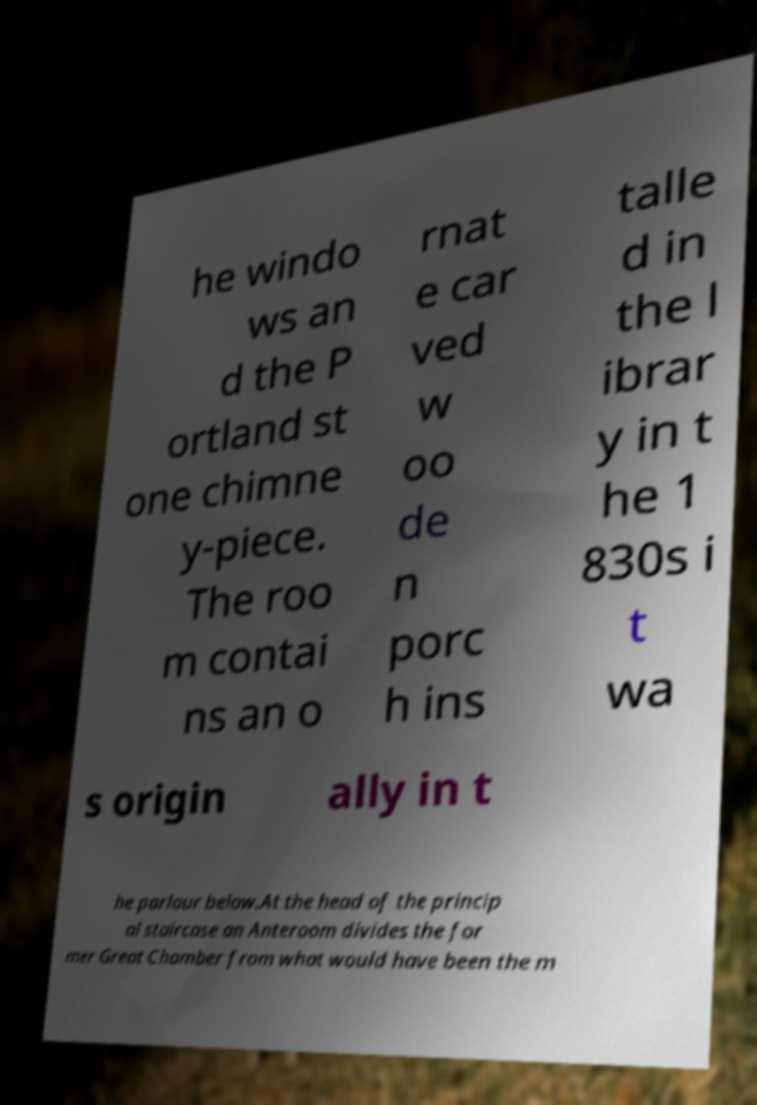Can you read and provide the text displayed in the image?This photo seems to have some interesting text. Can you extract and type it out for me? he windo ws an d the P ortland st one chimne y-piece. The roo m contai ns an o rnat e car ved w oo de n porc h ins talle d in the l ibrar y in t he 1 830s i t wa s origin ally in t he parlour below.At the head of the princip al staircase an Anteroom divides the for mer Great Chamber from what would have been the m 